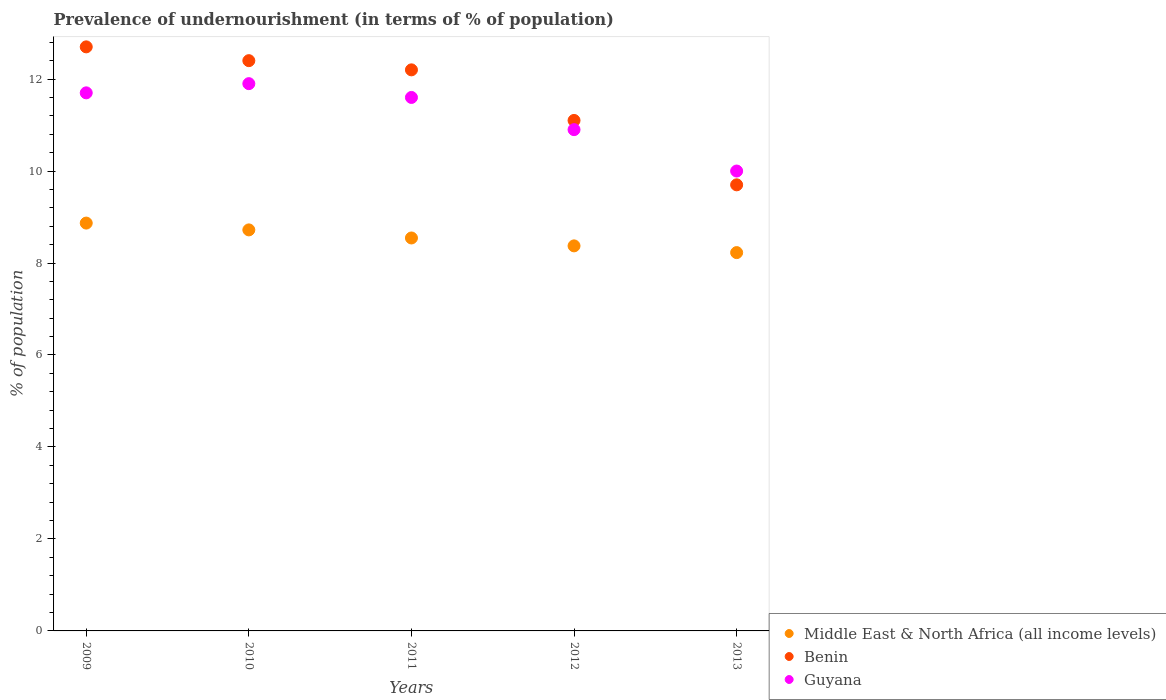How many different coloured dotlines are there?
Offer a terse response. 3. What is the percentage of undernourished population in Middle East & North Africa (all income levels) in 2012?
Offer a very short reply. 8.37. Across all years, what is the maximum percentage of undernourished population in Benin?
Provide a succinct answer. 12.7. In which year was the percentage of undernourished population in Middle East & North Africa (all income levels) maximum?
Offer a terse response. 2009. In which year was the percentage of undernourished population in Guyana minimum?
Your response must be concise. 2013. What is the total percentage of undernourished population in Benin in the graph?
Offer a terse response. 58.1. What is the difference between the percentage of undernourished population in Benin in 2009 and that in 2010?
Offer a very short reply. 0.3. What is the difference between the percentage of undernourished population in Benin in 2011 and the percentage of undernourished population in Guyana in 2012?
Your response must be concise. 1.3. What is the average percentage of undernourished population in Guyana per year?
Ensure brevity in your answer.  11.22. In the year 2012, what is the difference between the percentage of undernourished population in Guyana and percentage of undernourished population in Benin?
Offer a very short reply. -0.2. In how many years, is the percentage of undernourished population in Middle East & North Africa (all income levels) greater than 11.2 %?
Your answer should be compact. 0. What is the ratio of the percentage of undernourished population in Guyana in 2010 to that in 2011?
Keep it short and to the point. 1.03. Is the difference between the percentage of undernourished population in Guyana in 2010 and 2011 greater than the difference between the percentage of undernourished population in Benin in 2010 and 2011?
Offer a terse response. Yes. What is the difference between the highest and the second highest percentage of undernourished population in Middle East & North Africa (all income levels)?
Make the answer very short. 0.15. What is the difference between the highest and the lowest percentage of undernourished population in Benin?
Offer a terse response. 3. Is it the case that in every year, the sum of the percentage of undernourished population in Middle East & North Africa (all income levels) and percentage of undernourished population in Benin  is greater than the percentage of undernourished population in Guyana?
Ensure brevity in your answer.  Yes. Is the percentage of undernourished population in Guyana strictly greater than the percentage of undernourished population in Benin over the years?
Your response must be concise. No. Is the percentage of undernourished population in Benin strictly less than the percentage of undernourished population in Middle East & North Africa (all income levels) over the years?
Ensure brevity in your answer.  No. How many years are there in the graph?
Make the answer very short. 5. What is the difference between two consecutive major ticks on the Y-axis?
Keep it short and to the point. 2. Are the values on the major ticks of Y-axis written in scientific E-notation?
Keep it short and to the point. No. Does the graph contain grids?
Ensure brevity in your answer.  No. How many legend labels are there?
Provide a succinct answer. 3. What is the title of the graph?
Ensure brevity in your answer.  Prevalence of undernourishment (in terms of % of population). Does "Finland" appear as one of the legend labels in the graph?
Make the answer very short. No. What is the label or title of the X-axis?
Provide a succinct answer. Years. What is the label or title of the Y-axis?
Your answer should be very brief. % of population. What is the % of population of Middle East & North Africa (all income levels) in 2009?
Offer a terse response. 8.87. What is the % of population in Guyana in 2009?
Ensure brevity in your answer.  11.7. What is the % of population in Middle East & North Africa (all income levels) in 2010?
Your response must be concise. 8.72. What is the % of population of Guyana in 2010?
Offer a very short reply. 11.9. What is the % of population in Middle East & North Africa (all income levels) in 2011?
Give a very brief answer. 8.54. What is the % of population of Middle East & North Africa (all income levels) in 2012?
Give a very brief answer. 8.37. What is the % of population of Middle East & North Africa (all income levels) in 2013?
Offer a terse response. 8.23. What is the % of population in Benin in 2013?
Give a very brief answer. 9.7. Across all years, what is the maximum % of population in Middle East & North Africa (all income levels)?
Your answer should be compact. 8.87. Across all years, what is the maximum % of population in Benin?
Keep it short and to the point. 12.7. Across all years, what is the minimum % of population in Middle East & North Africa (all income levels)?
Your answer should be compact. 8.23. Across all years, what is the minimum % of population in Guyana?
Keep it short and to the point. 10. What is the total % of population in Middle East & North Africa (all income levels) in the graph?
Offer a terse response. 42.73. What is the total % of population in Benin in the graph?
Keep it short and to the point. 58.1. What is the total % of population in Guyana in the graph?
Your response must be concise. 56.1. What is the difference between the % of population of Middle East & North Africa (all income levels) in 2009 and that in 2010?
Make the answer very short. 0.15. What is the difference between the % of population of Guyana in 2009 and that in 2010?
Offer a very short reply. -0.2. What is the difference between the % of population of Middle East & North Africa (all income levels) in 2009 and that in 2011?
Your answer should be compact. 0.32. What is the difference between the % of population in Benin in 2009 and that in 2011?
Give a very brief answer. 0.5. What is the difference between the % of population of Middle East & North Africa (all income levels) in 2009 and that in 2012?
Your response must be concise. 0.5. What is the difference between the % of population of Benin in 2009 and that in 2012?
Give a very brief answer. 1.6. What is the difference between the % of population in Middle East & North Africa (all income levels) in 2009 and that in 2013?
Ensure brevity in your answer.  0.64. What is the difference between the % of population in Benin in 2009 and that in 2013?
Your answer should be very brief. 3. What is the difference between the % of population in Guyana in 2009 and that in 2013?
Your answer should be very brief. 1.7. What is the difference between the % of population of Middle East & North Africa (all income levels) in 2010 and that in 2011?
Offer a very short reply. 0.18. What is the difference between the % of population in Middle East & North Africa (all income levels) in 2010 and that in 2012?
Your response must be concise. 0.35. What is the difference between the % of population in Benin in 2010 and that in 2012?
Offer a very short reply. 1.3. What is the difference between the % of population in Guyana in 2010 and that in 2012?
Provide a succinct answer. 1. What is the difference between the % of population in Middle East & North Africa (all income levels) in 2010 and that in 2013?
Provide a short and direct response. 0.49. What is the difference between the % of population in Benin in 2010 and that in 2013?
Your response must be concise. 2.7. What is the difference between the % of population of Guyana in 2010 and that in 2013?
Make the answer very short. 1.9. What is the difference between the % of population in Middle East & North Africa (all income levels) in 2011 and that in 2012?
Keep it short and to the point. 0.17. What is the difference between the % of population in Benin in 2011 and that in 2012?
Your response must be concise. 1.1. What is the difference between the % of population in Guyana in 2011 and that in 2012?
Your answer should be compact. 0.7. What is the difference between the % of population of Middle East & North Africa (all income levels) in 2011 and that in 2013?
Give a very brief answer. 0.32. What is the difference between the % of population in Middle East & North Africa (all income levels) in 2012 and that in 2013?
Provide a succinct answer. 0.15. What is the difference between the % of population in Benin in 2012 and that in 2013?
Give a very brief answer. 1.4. What is the difference between the % of population of Guyana in 2012 and that in 2013?
Offer a very short reply. 0.9. What is the difference between the % of population of Middle East & North Africa (all income levels) in 2009 and the % of population of Benin in 2010?
Your answer should be very brief. -3.53. What is the difference between the % of population in Middle East & North Africa (all income levels) in 2009 and the % of population in Guyana in 2010?
Make the answer very short. -3.03. What is the difference between the % of population in Middle East & North Africa (all income levels) in 2009 and the % of population in Benin in 2011?
Ensure brevity in your answer.  -3.33. What is the difference between the % of population in Middle East & North Africa (all income levels) in 2009 and the % of population in Guyana in 2011?
Your response must be concise. -2.73. What is the difference between the % of population of Middle East & North Africa (all income levels) in 2009 and the % of population of Benin in 2012?
Make the answer very short. -2.23. What is the difference between the % of population of Middle East & North Africa (all income levels) in 2009 and the % of population of Guyana in 2012?
Provide a short and direct response. -2.03. What is the difference between the % of population of Benin in 2009 and the % of population of Guyana in 2012?
Provide a short and direct response. 1.8. What is the difference between the % of population in Middle East & North Africa (all income levels) in 2009 and the % of population in Benin in 2013?
Ensure brevity in your answer.  -0.83. What is the difference between the % of population in Middle East & North Africa (all income levels) in 2009 and the % of population in Guyana in 2013?
Ensure brevity in your answer.  -1.13. What is the difference between the % of population in Middle East & North Africa (all income levels) in 2010 and the % of population in Benin in 2011?
Your answer should be very brief. -3.48. What is the difference between the % of population in Middle East & North Africa (all income levels) in 2010 and the % of population in Guyana in 2011?
Offer a very short reply. -2.88. What is the difference between the % of population of Middle East & North Africa (all income levels) in 2010 and the % of population of Benin in 2012?
Offer a very short reply. -2.38. What is the difference between the % of population in Middle East & North Africa (all income levels) in 2010 and the % of population in Guyana in 2012?
Your response must be concise. -2.18. What is the difference between the % of population of Benin in 2010 and the % of population of Guyana in 2012?
Offer a very short reply. 1.5. What is the difference between the % of population in Middle East & North Africa (all income levels) in 2010 and the % of population in Benin in 2013?
Your response must be concise. -0.98. What is the difference between the % of population of Middle East & North Africa (all income levels) in 2010 and the % of population of Guyana in 2013?
Your response must be concise. -1.28. What is the difference between the % of population of Benin in 2010 and the % of population of Guyana in 2013?
Offer a very short reply. 2.4. What is the difference between the % of population of Middle East & North Africa (all income levels) in 2011 and the % of population of Benin in 2012?
Give a very brief answer. -2.56. What is the difference between the % of population of Middle East & North Africa (all income levels) in 2011 and the % of population of Guyana in 2012?
Keep it short and to the point. -2.36. What is the difference between the % of population of Middle East & North Africa (all income levels) in 2011 and the % of population of Benin in 2013?
Give a very brief answer. -1.16. What is the difference between the % of population of Middle East & North Africa (all income levels) in 2011 and the % of population of Guyana in 2013?
Your answer should be very brief. -1.46. What is the difference between the % of population in Benin in 2011 and the % of population in Guyana in 2013?
Your answer should be compact. 2.2. What is the difference between the % of population in Middle East & North Africa (all income levels) in 2012 and the % of population in Benin in 2013?
Ensure brevity in your answer.  -1.33. What is the difference between the % of population in Middle East & North Africa (all income levels) in 2012 and the % of population in Guyana in 2013?
Offer a terse response. -1.63. What is the difference between the % of population in Benin in 2012 and the % of population in Guyana in 2013?
Keep it short and to the point. 1.1. What is the average % of population in Middle East & North Africa (all income levels) per year?
Your answer should be compact. 8.55. What is the average % of population in Benin per year?
Make the answer very short. 11.62. What is the average % of population of Guyana per year?
Offer a terse response. 11.22. In the year 2009, what is the difference between the % of population in Middle East & North Africa (all income levels) and % of population in Benin?
Your response must be concise. -3.83. In the year 2009, what is the difference between the % of population in Middle East & North Africa (all income levels) and % of population in Guyana?
Your answer should be compact. -2.83. In the year 2010, what is the difference between the % of population in Middle East & North Africa (all income levels) and % of population in Benin?
Give a very brief answer. -3.68. In the year 2010, what is the difference between the % of population of Middle East & North Africa (all income levels) and % of population of Guyana?
Your response must be concise. -3.18. In the year 2011, what is the difference between the % of population of Middle East & North Africa (all income levels) and % of population of Benin?
Make the answer very short. -3.66. In the year 2011, what is the difference between the % of population of Middle East & North Africa (all income levels) and % of population of Guyana?
Ensure brevity in your answer.  -3.06. In the year 2012, what is the difference between the % of population of Middle East & North Africa (all income levels) and % of population of Benin?
Offer a terse response. -2.73. In the year 2012, what is the difference between the % of population of Middle East & North Africa (all income levels) and % of population of Guyana?
Keep it short and to the point. -2.53. In the year 2012, what is the difference between the % of population of Benin and % of population of Guyana?
Your answer should be very brief. 0.2. In the year 2013, what is the difference between the % of population of Middle East & North Africa (all income levels) and % of population of Benin?
Offer a terse response. -1.47. In the year 2013, what is the difference between the % of population of Middle East & North Africa (all income levels) and % of population of Guyana?
Your answer should be very brief. -1.77. In the year 2013, what is the difference between the % of population of Benin and % of population of Guyana?
Provide a short and direct response. -0.3. What is the ratio of the % of population in Benin in 2009 to that in 2010?
Ensure brevity in your answer.  1.02. What is the ratio of the % of population in Guyana in 2009 to that in 2010?
Your response must be concise. 0.98. What is the ratio of the % of population in Middle East & North Africa (all income levels) in 2009 to that in 2011?
Make the answer very short. 1.04. What is the ratio of the % of population in Benin in 2009 to that in 2011?
Give a very brief answer. 1.04. What is the ratio of the % of population in Guyana in 2009 to that in 2011?
Provide a short and direct response. 1.01. What is the ratio of the % of population in Middle East & North Africa (all income levels) in 2009 to that in 2012?
Ensure brevity in your answer.  1.06. What is the ratio of the % of population in Benin in 2009 to that in 2012?
Give a very brief answer. 1.14. What is the ratio of the % of population in Guyana in 2009 to that in 2012?
Make the answer very short. 1.07. What is the ratio of the % of population in Middle East & North Africa (all income levels) in 2009 to that in 2013?
Offer a terse response. 1.08. What is the ratio of the % of population of Benin in 2009 to that in 2013?
Give a very brief answer. 1.31. What is the ratio of the % of population in Guyana in 2009 to that in 2013?
Offer a very short reply. 1.17. What is the ratio of the % of population of Middle East & North Africa (all income levels) in 2010 to that in 2011?
Offer a terse response. 1.02. What is the ratio of the % of population of Benin in 2010 to that in 2011?
Give a very brief answer. 1.02. What is the ratio of the % of population in Guyana in 2010 to that in 2011?
Provide a short and direct response. 1.03. What is the ratio of the % of population of Middle East & North Africa (all income levels) in 2010 to that in 2012?
Your answer should be very brief. 1.04. What is the ratio of the % of population of Benin in 2010 to that in 2012?
Ensure brevity in your answer.  1.12. What is the ratio of the % of population of Guyana in 2010 to that in 2012?
Provide a short and direct response. 1.09. What is the ratio of the % of population of Middle East & North Africa (all income levels) in 2010 to that in 2013?
Make the answer very short. 1.06. What is the ratio of the % of population in Benin in 2010 to that in 2013?
Keep it short and to the point. 1.28. What is the ratio of the % of population of Guyana in 2010 to that in 2013?
Provide a short and direct response. 1.19. What is the ratio of the % of population of Middle East & North Africa (all income levels) in 2011 to that in 2012?
Provide a succinct answer. 1.02. What is the ratio of the % of population in Benin in 2011 to that in 2012?
Your response must be concise. 1.1. What is the ratio of the % of population of Guyana in 2011 to that in 2012?
Your answer should be very brief. 1.06. What is the ratio of the % of population in Middle East & North Africa (all income levels) in 2011 to that in 2013?
Your response must be concise. 1.04. What is the ratio of the % of population of Benin in 2011 to that in 2013?
Provide a succinct answer. 1.26. What is the ratio of the % of population of Guyana in 2011 to that in 2013?
Your response must be concise. 1.16. What is the ratio of the % of population in Middle East & North Africa (all income levels) in 2012 to that in 2013?
Make the answer very short. 1.02. What is the ratio of the % of population in Benin in 2012 to that in 2013?
Your answer should be compact. 1.14. What is the ratio of the % of population of Guyana in 2012 to that in 2013?
Provide a succinct answer. 1.09. What is the difference between the highest and the second highest % of population in Middle East & North Africa (all income levels)?
Give a very brief answer. 0.15. What is the difference between the highest and the lowest % of population of Middle East & North Africa (all income levels)?
Your answer should be compact. 0.64. What is the difference between the highest and the lowest % of population of Benin?
Keep it short and to the point. 3. 